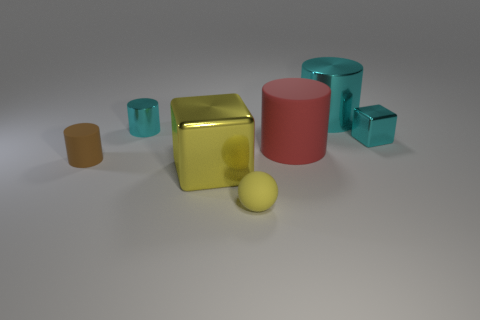Add 2 big red rubber cylinders. How many objects exist? 9 Subtract all balls. How many objects are left? 6 Subtract all tiny yellow things. Subtract all big yellow metal things. How many objects are left? 5 Add 3 matte objects. How many matte objects are left? 6 Add 6 yellow shiny things. How many yellow shiny things exist? 7 Subtract 0 brown balls. How many objects are left? 7 